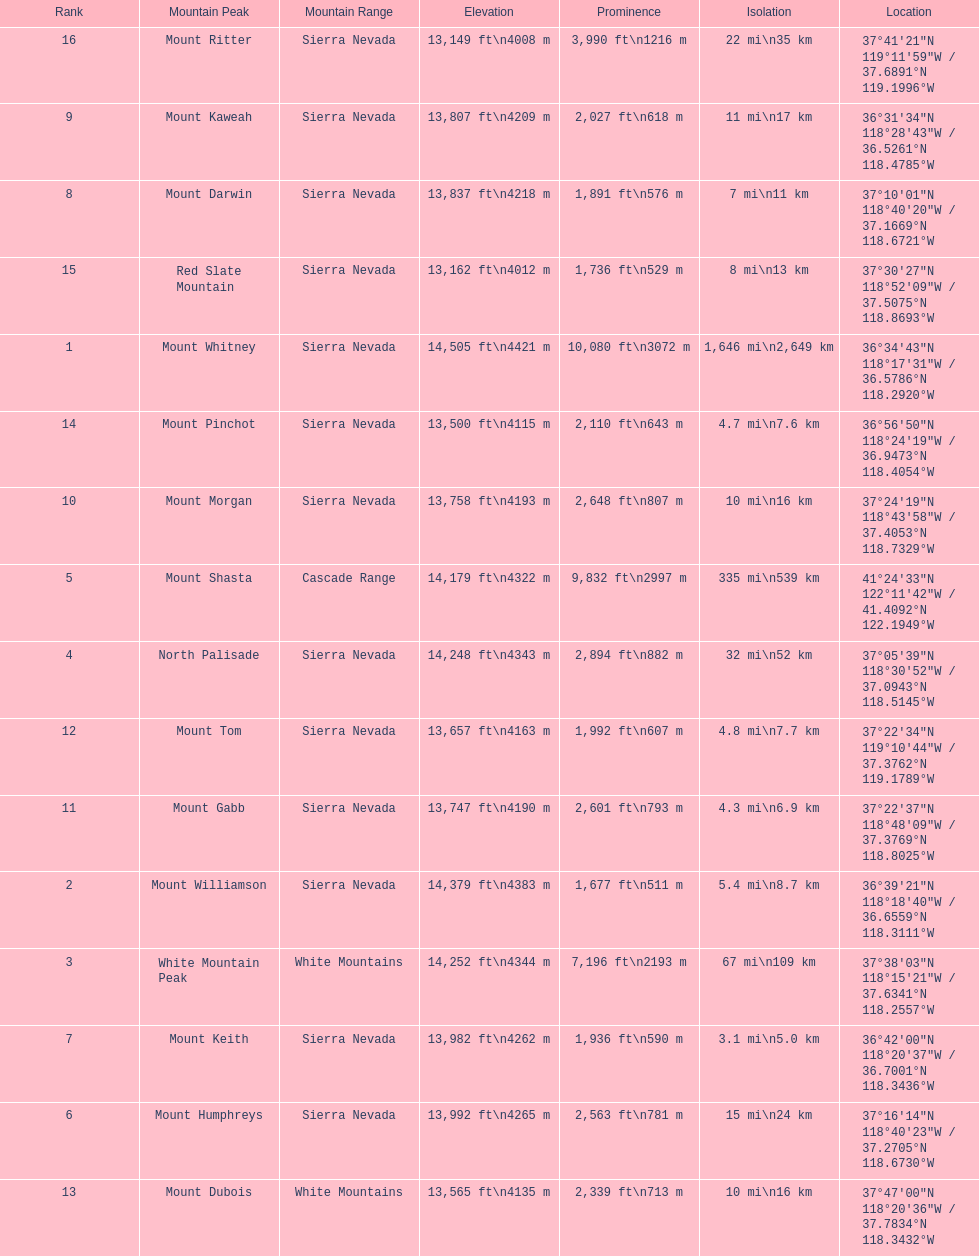Would you mind parsing the complete table? {'header': ['Rank', 'Mountain Peak', 'Mountain Range', 'Elevation', 'Prominence', 'Isolation', 'Location'], 'rows': [['16', 'Mount Ritter', 'Sierra Nevada', '13,149\xa0ft\\n4008\xa0m', '3,990\xa0ft\\n1216\xa0m', '22\xa0mi\\n35\xa0km', '37°41′21″N 119°11′59″W\ufeff / \ufeff37.6891°N 119.1996°W'], ['9', 'Mount Kaweah', 'Sierra Nevada', '13,807\xa0ft\\n4209\xa0m', '2,027\xa0ft\\n618\xa0m', '11\xa0mi\\n17\xa0km', '36°31′34″N 118°28′43″W\ufeff / \ufeff36.5261°N 118.4785°W'], ['8', 'Mount Darwin', 'Sierra Nevada', '13,837\xa0ft\\n4218\xa0m', '1,891\xa0ft\\n576\xa0m', '7\xa0mi\\n11\xa0km', '37°10′01″N 118°40′20″W\ufeff / \ufeff37.1669°N 118.6721°W'], ['15', 'Red Slate Mountain', 'Sierra Nevada', '13,162\xa0ft\\n4012\xa0m', '1,736\xa0ft\\n529\xa0m', '8\xa0mi\\n13\xa0km', '37°30′27″N 118°52′09″W\ufeff / \ufeff37.5075°N 118.8693°W'], ['1', 'Mount Whitney', 'Sierra Nevada', '14,505\xa0ft\\n4421\xa0m', '10,080\xa0ft\\n3072\xa0m', '1,646\xa0mi\\n2,649\xa0km', '36°34′43″N 118°17′31″W\ufeff / \ufeff36.5786°N 118.2920°W'], ['14', 'Mount Pinchot', 'Sierra Nevada', '13,500\xa0ft\\n4115\xa0m', '2,110\xa0ft\\n643\xa0m', '4.7\xa0mi\\n7.6\xa0km', '36°56′50″N 118°24′19″W\ufeff / \ufeff36.9473°N 118.4054°W'], ['10', 'Mount Morgan', 'Sierra Nevada', '13,758\xa0ft\\n4193\xa0m', '2,648\xa0ft\\n807\xa0m', '10\xa0mi\\n16\xa0km', '37°24′19″N 118°43′58″W\ufeff / \ufeff37.4053°N 118.7329°W'], ['5', 'Mount Shasta', 'Cascade Range', '14,179\xa0ft\\n4322\xa0m', '9,832\xa0ft\\n2997\xa0m', '335\xa0mi\\n539\xa0km', '41°24′33″N 122°11′42″W\ufeff / \ufeff41.4092°N 122.1949°W'], ['4', 'North Palisade', 'Sierra Nevada', '14,248\xa0ft\\n4343\xa0m', '2,894\xa0ft\\n882\xa0m', '32\xa0mi\\n52\xa0km', '37°05′39″N 118°30′52″W\ufeff / \ufeff37.0943°N 118.5145°W'], ['12', 'Mount Tom', 'Sierra Nevada', '13,657\xa0ft\\n4163\xa0m', '1,992\xa0ft\\n607\xa0m', '4.8\xa0mi\\n7.7\xa0km', '37°22′34″N 119°10′44″W\ufeff / \ufeff37.3762°N 119.1789°W'], ['11', 'Mount Gabb', 'Sierra Nevada', '13,747\xa0ft\\n4190\xa0m', '2,601\xa0ft\\n793\xa0m', '4.3\xa0mi\\n6.9\xa0km', '37°22′37″N 118°48′09″W\ufeff / \ufeff37.3769°N 118.8025°W'], ['2', 'Mount Williamson', 'Sierra Nevada', '14,379\xa0ft\\n4383\xa0m', '1,677\xa0ft\\n511\xa0m', '5.4\xa0mi\\n8.7\xa0km', '36°39′21″N 118°18′40″W\ufeff / \ufeff36.6559°N 118.3111°W'], ['3', 'White Mountain Peak', 'White Mountains', '14,252\xa0ft\\n4344\xa0m', '7,196\xa0ft\\n2193\xa0m', '67\xa0mi\\n109\xa0km', '37°38′03″N 118°15′21″W\ufeff / \ufeff37.6341°N 118.2557°W'], ['7', 'Mount Keith', 'Sierra Nevada', '13,982\xa0ft\\n4262\xa0m', '1,936\xa0ft\\n590\xa0m', '3.1\xa0mi\\n5.0\xa0km', '36°42′00″N 118°20′37″W\ufeff / \ufeff36.7001°N 118.3436°W'], ['6', 'Mount Humphreys', 'Sierra Nevada', '13,992\xa0ft\\n4265\xa0m', '2,563\xa0ft\\n781\xa0m', '15\xa0mi\\n24\xa0km', '37°16′14″N 118°40′23″W\ufeff / \ufeff37.2705°N 118.6730°W'], ['13', 'Mount Dubois', 'White Mountains', '13,565\xa0ft\\n4135\xa0m', '2,339\xa0ft\\n713\xa0m', '10\xa0mi\\n16\xa0km', '37°47′00″N 118°20′36″W\ufeff / \ufeff37.7834°N 118.3432°W']]} What is the total elevation (in ft) of mount whitney? 14,505 ft. 